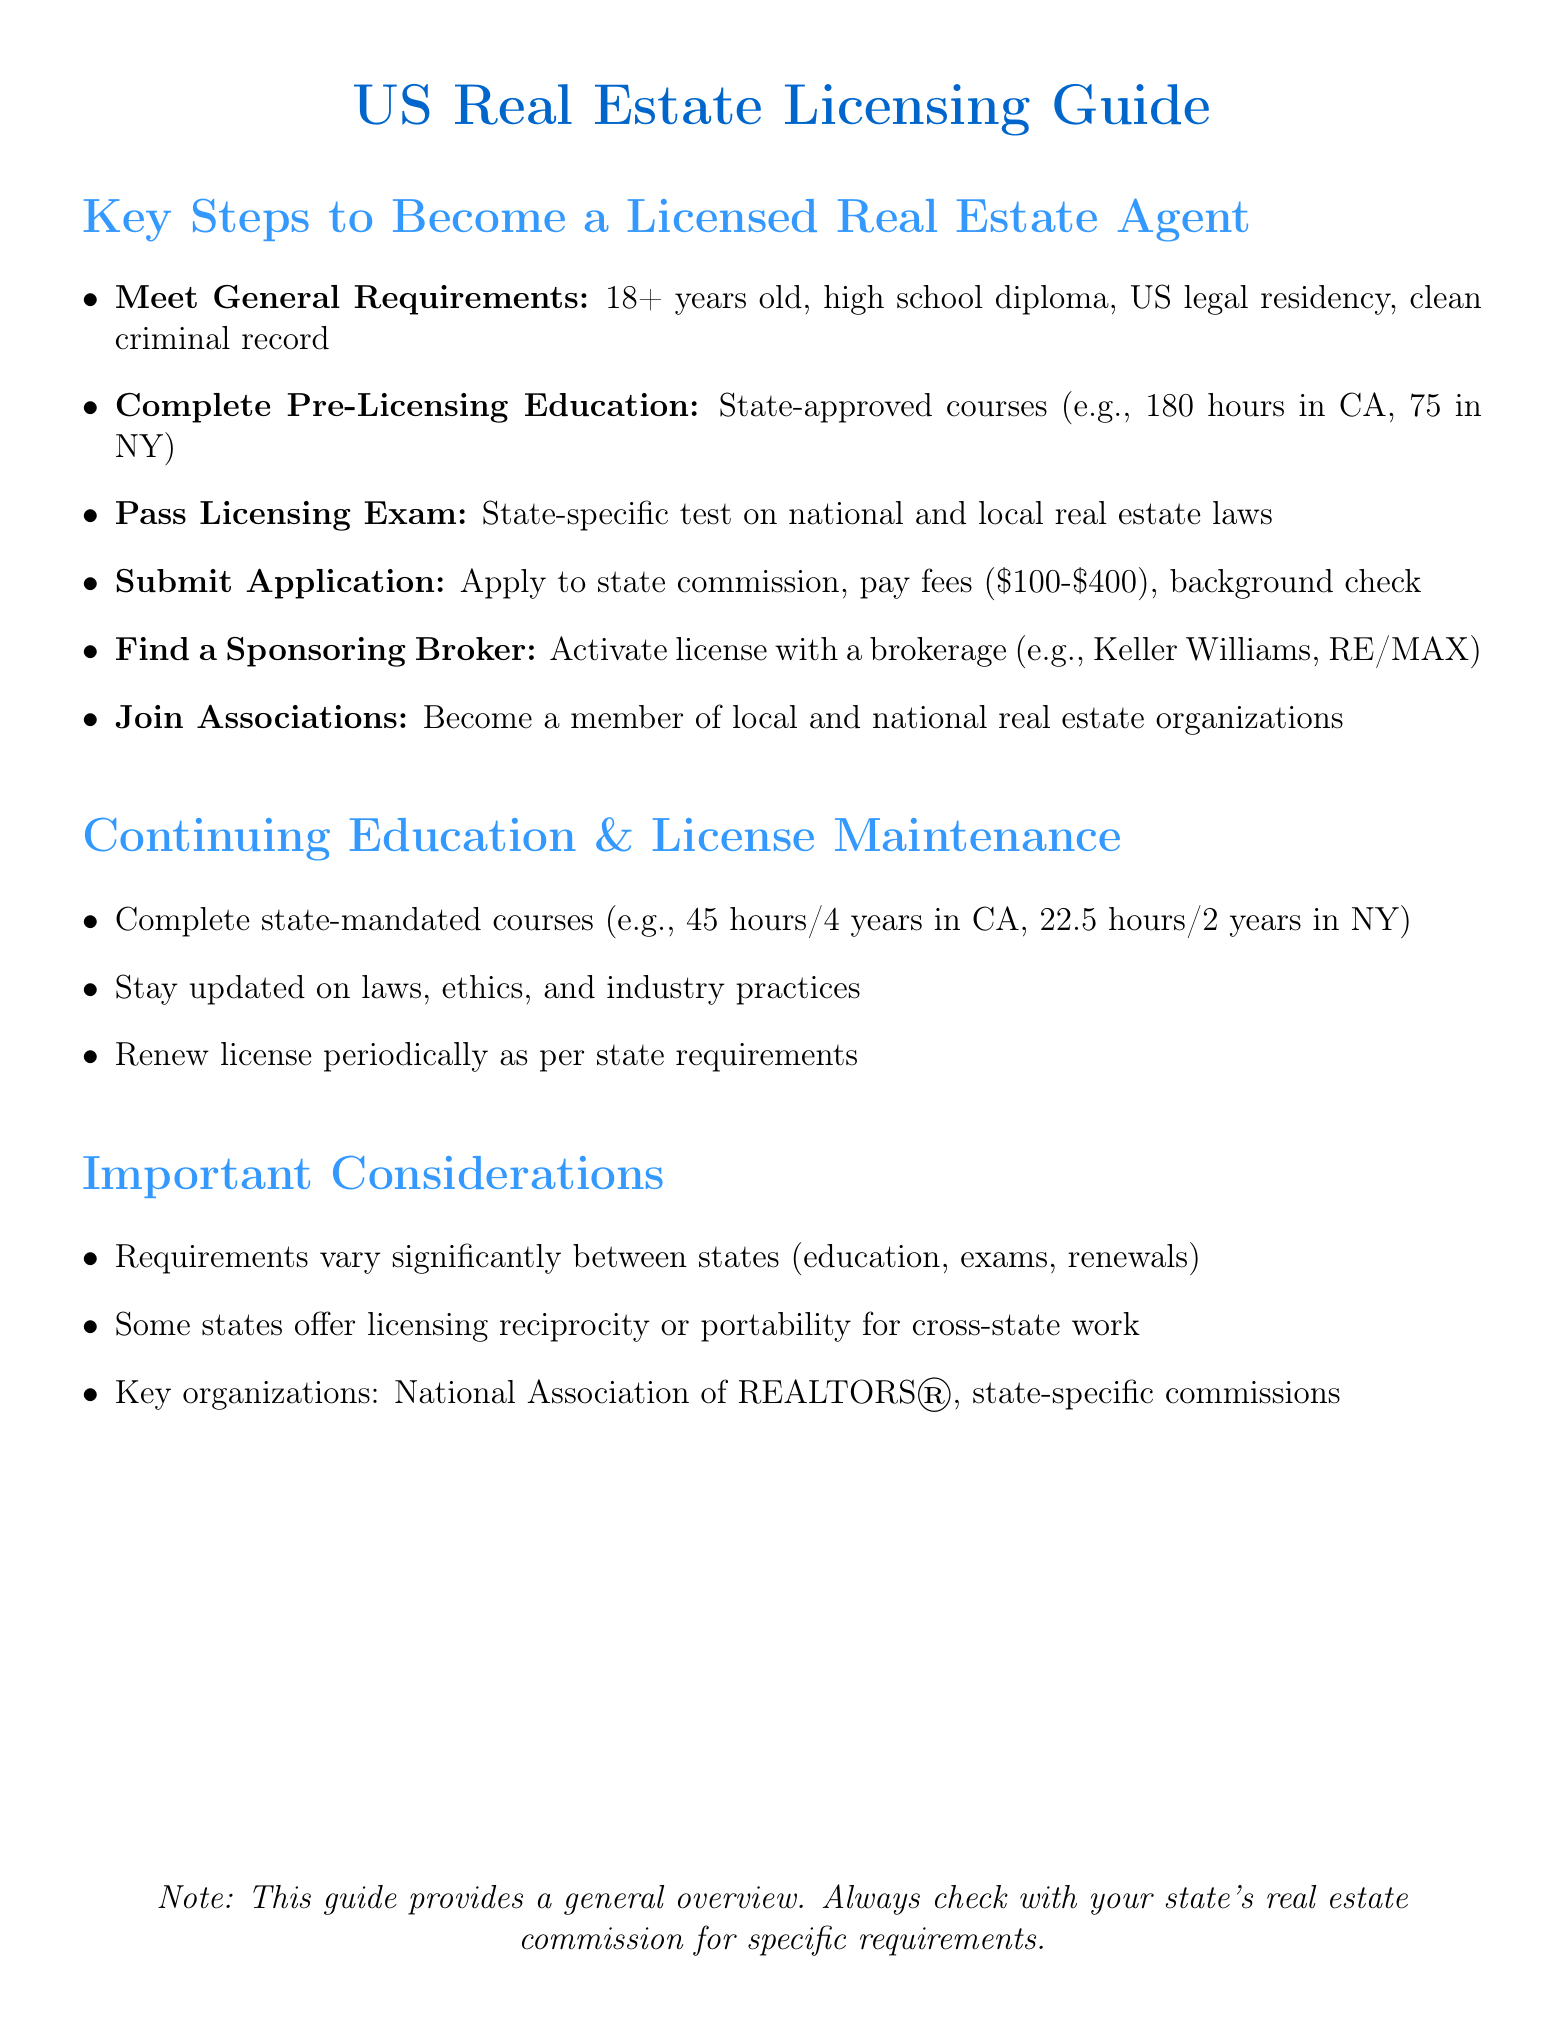What is the minimum age requirement to become a licensed real estate agent? The minimum age requirement is stated as typically 18 years old in the document.
Answer: 18 years old How many course hours are required for pre-licensing education in California? The document specifies that California requires 180 hours of pre-licensing education.
Answer: 180 hours What is the range of application and licensing fees mentioned? The document indicates that the application and licensing fees range from $100 to $400.
Answer: $100 to $400 What type of exam must be passed to obtain a real estate license? According to the document, the licensing exam is state-specific and covers national and state-specific real estate laws and practices.
Answer: State-specific exam Which organization is mentioned as a key association for real estate agents? The document lists the National Association of REALTORS® as a key organization.
Answer: National Association of REALTORS® How often are continuing education courses required in New York? The document states that New York requires 22.5 hours of continuing education every 2 years.
Answer: 22.5 hours every 2 years What is one notable difference between state requirements for real estate licensing mentioned? The document notes that education requirements and exam difficulty vary significantly between states.
Answer: Education requirements and exam difficulty What must be submitted along with the application for a real estate license? The document specifies that fingerprints for a background check must be provided along with the application.
Answer: Fingerprints for background check Which states offer licensing reciprocity mentioned in the document? The document indicates that New York has reciprocity with 9 states, but does not list all of them.
Answer: New York has reciprocity with 9 states 